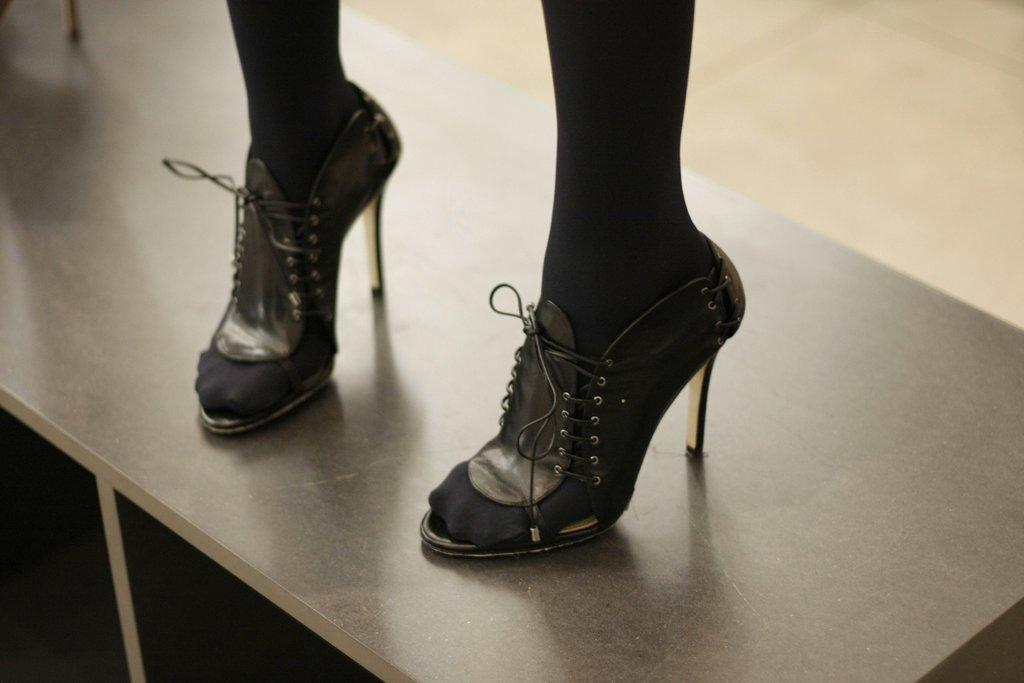What type of furniture is present in the image? There is a table in the image. What is positioned on the table? A person's legs are visible on the table. What type of footwear is the person wearing? The person is wearing sandals. What can be seen on the person's feet? The person is wearing black socks. What type of mine is visible in the image? There is no mine present in the image. How does the person stretch their legs on the table? The image does not show the person stretching their legs; their legs are simply positioned on the table. 